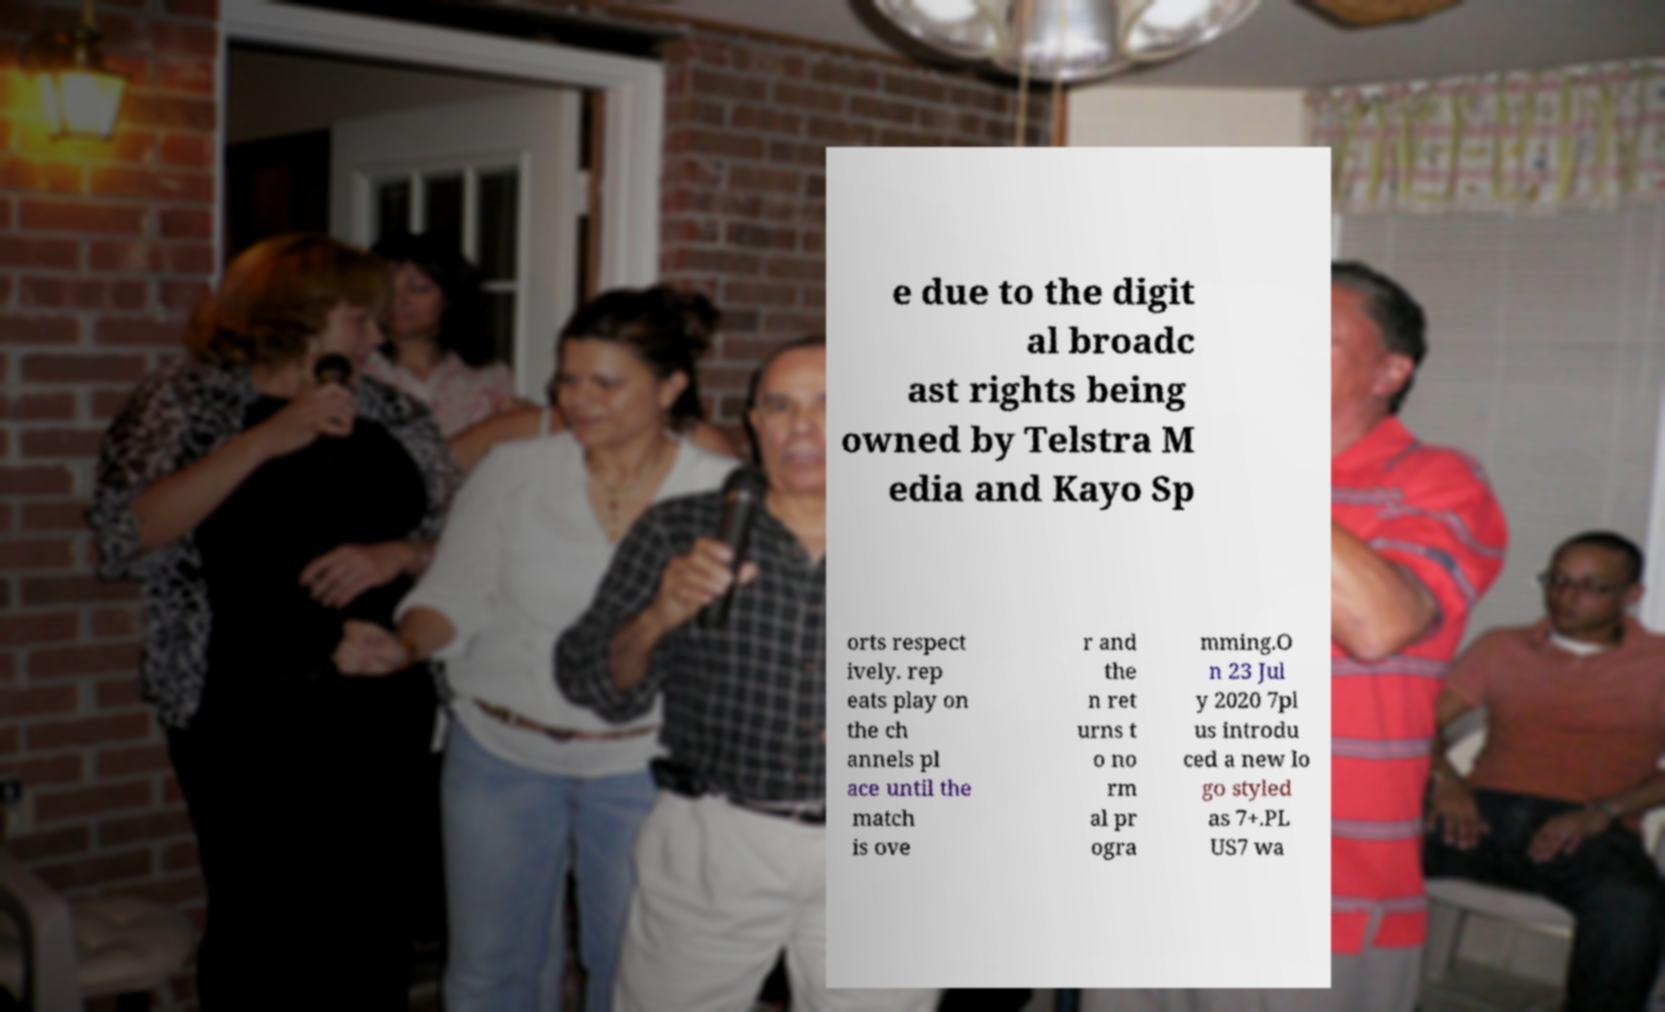Could you assist in decoding the text presented in this image and type it out clearly? e due to the digit al broadc ast rights being owned by Telstra M edia and Kayo Sp orts respect ively. rep eats play on the ch annels pl ace until the match is ove r and the n ret urns t o no rm al pr ogra mming.O n 23 Jul y 2020 7pl us introdu ced a new lo go styled as 7+.PL US7 wa 